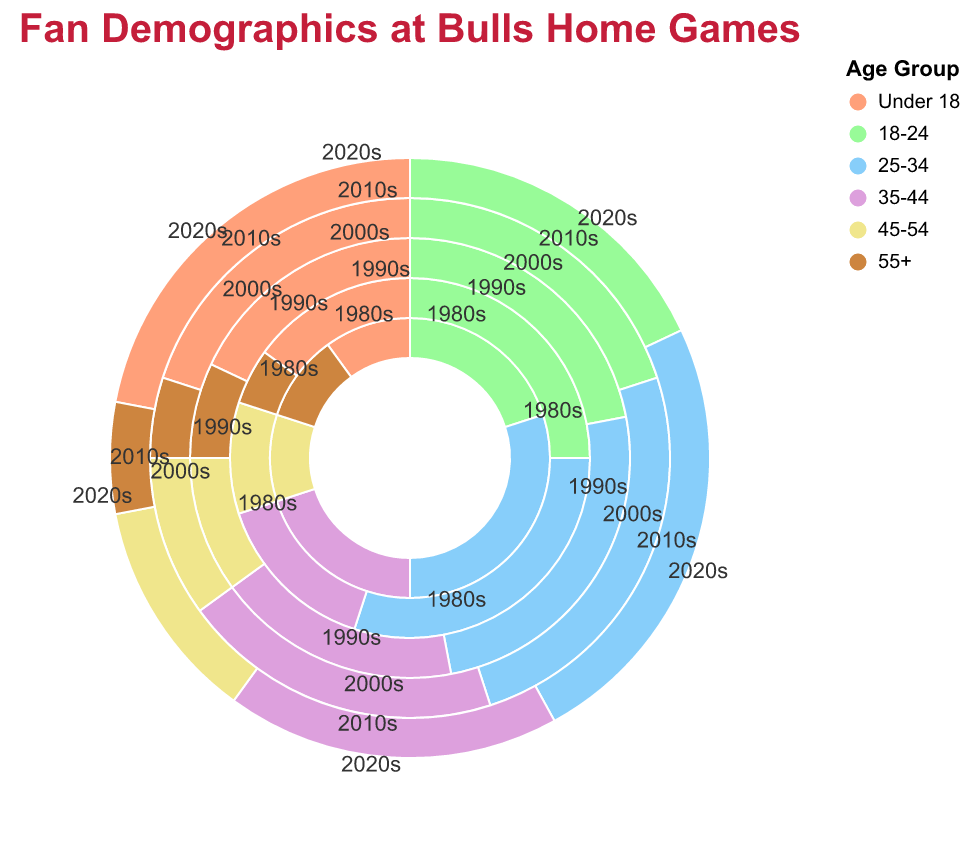What is the title of the figure? The title is often displayed prominently at the top of the chart and should describe what the chart is about.
Answer: Fan Demographics at Bulls Home Games Which decade has the highest percentage of fans aged 25-34? To find this, compare the percentages for the 25-34 age group in each decade.
Answer: 1980s and 1990s (both have 30%) How does the percentage of fans aged 55+ in the 1990s compare to the 2020s? Compare the percentages in the '55+' category for the 1990s and the 2020s.
Answer: The percentage is higher in the 2020s (6%) compared to the 1990s (5%) What is the trend for the under-18 age group from the 1980s to the 2020s? Observe the 'Under 18' percentages and describe the pattern over the decades.
Answer: Increasing Which age group had the most stable percentage across all decades? Compare the variability in percentages across all decades for each age group.
Answer: 45-54 What is the combined percentage of fans aged 18-24 and 25-34 in the 2010s? Add the percentages for the 18-24 and 25-34 age groups in the 2010s.
Answer: 45% Which decade had the lowest percentage of fans aged 45-54 and under 18 combined? Add the percentages for the 'Under 18' and '45-54' groups for each decade, then find the lowest.
Answer: 1990s (25%) What is the difference in percentage between fans aged 35-44 in the 2000s and the 2020s? Subtract the percentage of the 2020s from the 2000s for the 35-44 age group.
Answer: 0% How does the percentage of fans aged 18-24 in the 1980s compare to the 1990s? Compare the percentages in the '18-24' category for the 1980s and the 1990s.
Answer: Higher in the 1990s (25%) than in the 1980s (20%) Which decade shows the maximum diversity among different age groups? Find the decade where the range (max-min) of percentages among age groups is the largest.
Answer: 1980s 